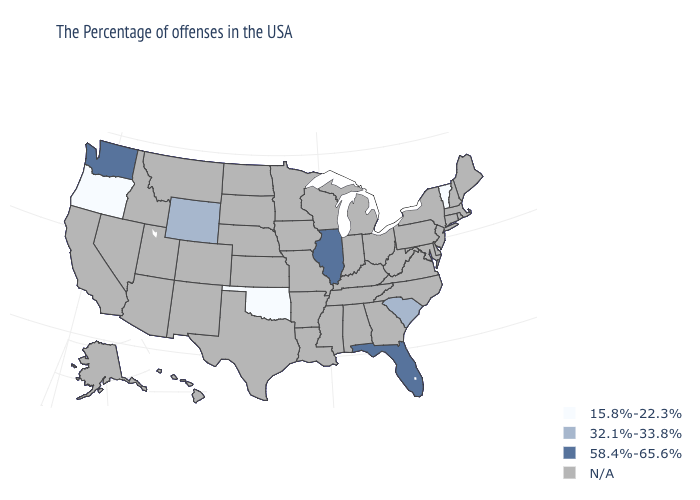Which states hav the highest value in the South?
Concise answer only. Florida. What is the value of Colorado?
Short answer required. N/A. Among the states that border Utah , which have the highest value?
Quick response, please. Wyoming. Name the states that have a value in the range 58.4%-65.6%?
Keep it brief. Florida, Illinois, Washington. What is the value of Pennsylvania?
Quick response, please. N/A. What is the highest value in the USA?
Be succinct. 58.4%-65.6%. Is the legend a continuous bar?
Concise answer only. No. What is the value of Maryland?
Short answer required. N/A. Among the states that border Idaho , which have the highest value?
Give a very brief answer. Washington. What is the highest value in the USA?
Be succinct. 58.4%-65.6%. Which states have the highest value in the USA?
Keep it brief. Florida, Illinois, Washington. Does the map have missing data?
Be succinct. Yes. Is the legend a continuous bar?
Be succinct. No. 